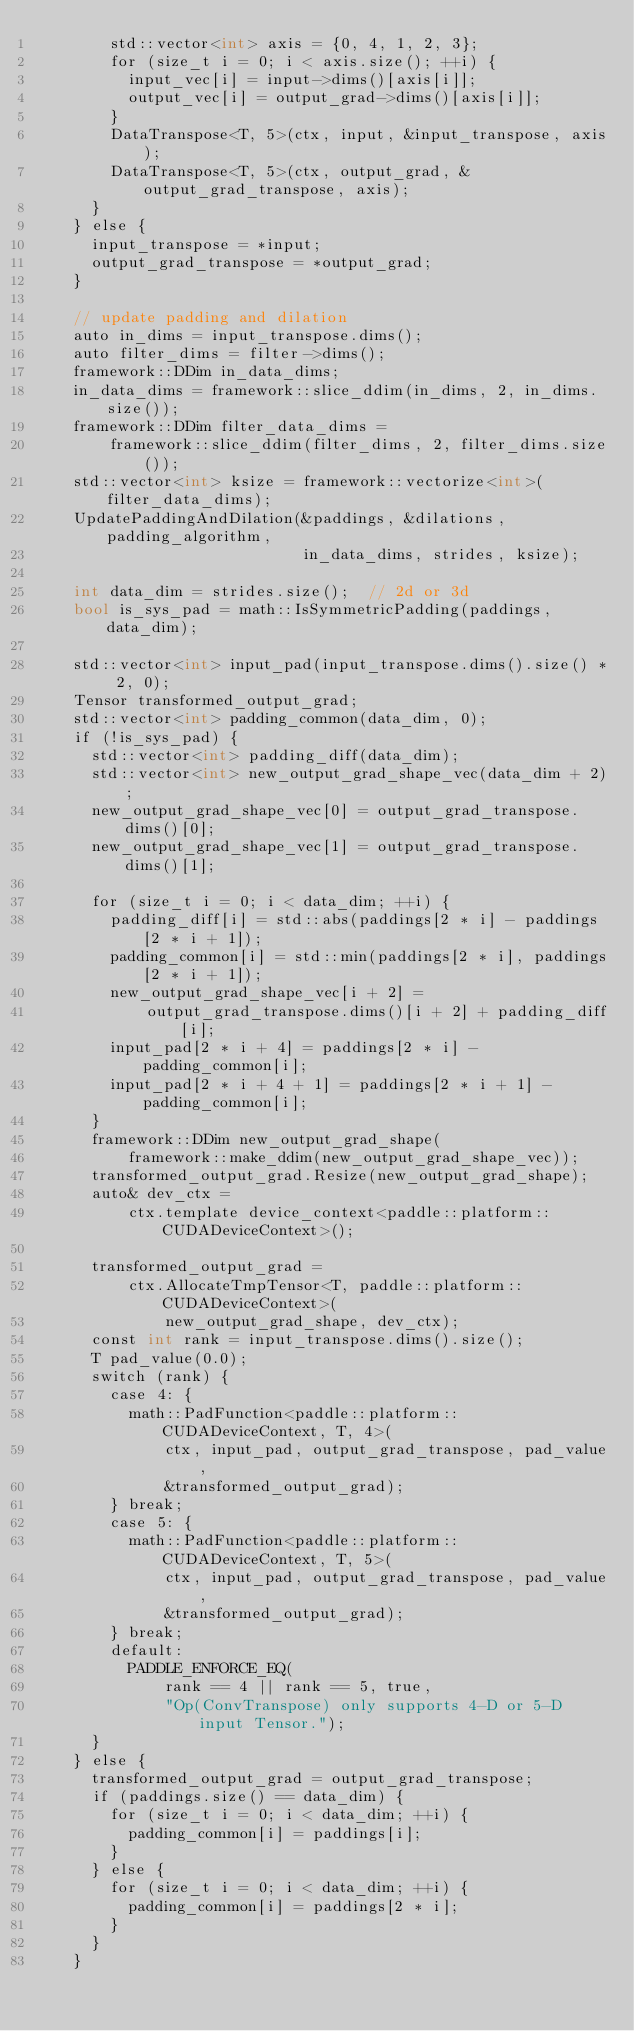Convert code to text. <code><loc_0><loc_0><loc_500><loc_500><_Cuda_>        std::vector<int> axis = {0, 4, 1, 2, 3};
        for (size_t i = 0; i < axis.size(); ++i) {
          input_vec[i] = input->dims()[axis[i]];
          output_vec[i] = output_grad->dims()[axis[i]];
        }
        DataTranspose<T, 5>(ctx, input, &input_transpose, axis);
        DataTranspose<T, 5>(ctx, output_grad, &output_grad_transpose, axis);
      }
    } else {
      input_transpose = *input;
      output_grad_transpose = *output_grad;
    }

    // update padding and dilation
    auto in_dims = input_transpose.dims();
    auto filter_dims = filter->dims();
    framework::DDim in_data_dims;
    in_data_dims = framework::slice_ddim(in_dims, 2, in_dims.size());
    framework::DDim filter_data_dims =
        framework::slice_ddim(filter_dims, 2, filter_dims.size());
    std::vector<int> ksize = framework::vectorize<int>(filter_data_dims);
    UpdatePaddingAndDilation(&paddings, &dilations, padding_algorithm,
                             in_data_dims, strides, ksize);

    int data_dim = strides.size();  // 2d or 3d
    bool is_sys_pad = math::IsSymmetricPadding(paddings, data_dim);

    std::vector<int> input_pad(input_transpose.dims().size() * 2, 0);
    Tensor transformed_output_grad;
    std::vector<int> padding_common(data_dim, 0);
    if (!is_sys_pad) {
      std::vector<int> padding_diff(data_dim);
      std::vector<int> new_output_grad_shape_vec(data_dim + 2);
      new_output_grad_shape_vec[0] = output_grad_transpose.dims()[0];
      new_output_grad_shape_vec[1] = output_grad_transpose.dims()[1];

      for (size_t i = 0; i < data_dim; ++i) {
        padding_diff[i] = std::abs(paddings[2 * i] - paddings[2 * i + 1]);
        padding_common[i] = std::min(paddings[2 * i], paddings[2 * i + 1]);
        new_output_grad_shape_vec[i + 2] =
            output_grad_transpose.dims()[i + 2] + padding_diff[i];
        input_pad[2 * i + 4] = paddings[2 * i] - padding_common[i];
        input_pad[2 * i + 4 + 1] = paddings[2 * i + 1] - padding_common[i];
      }
      framework::DDim new_output_grad_shape(
          framework::make_ddim(new_output_grad_shape_vec));
      transformed_output_grad.Resize(new_output_grad_shape);
      auto& dev_ctx =
          ctx.template device_context<paddle::platform::CUDADeviceContext>();

      transformed_output_grad =
          ctx.AllocateTmpTensor<T, paddle::platform::CUDADeviceContext>(
              new_output_grad_shape, dev_ctx);
      const int rank = input_transpose.dims().size();
      T pad_value(0.0);
      switch (rank) {
        case 4: {
          math::PadFunction<paddle::platform::CUDADeviceContext, T, 4>(
              ctx, input_pad, output_grad_transpose, pad_value,
              &transformed_output_grad);
        } break;
        case 5: {
          math::PadFunction<paddle::platform::CUDADeviceContext, T, 5>(
              ctx, input_pad, output_grad_transpose, pad_value,
              &transformed_output_grad);
        } break;
        default:
          PADDLE_ENFORCE_EQ(
              rank == 4 || rank == 5, true,
              "Op(ConvTranspose) only supports 4-D or 5-D input Tensor.");
      }
    } else {
      transformed_output_grad = output_grad_transpose;
      if (paddings.size() == data_dim) {
        for (size_t i = 0; i < data_dim; ++i) {
          padding_common[i] = paddings[i];
        }
      } else {
        for (size_t i = 0; i < data_dim; ++i) {
          padding_common[i] = paddings[2 * i];
        }
      }
    }
</code> 